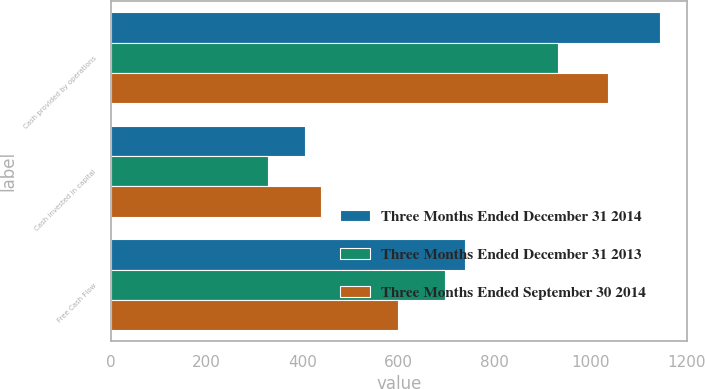<chart> <loc_0><loc_0><loc_500><loc_500><stacked_bar_chart><ecel><fcel>Cash provided by operations<fcel>Cash invested in capital<fcel>Free Cash Flow<nl><fcel>Three Months Ended December 31 2014<fcel>1144<fcel>405<fcel>739<nl><fcel>Three Months Ended December 31 2013<fcel>933<fcel>327<fcel>696<nl><fcel>Three Months Ended September 30 2014<fcel>1037<fcel>439<fcel>598<nl></chart> 